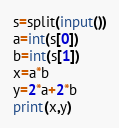Convert code to text. <code><loc_0><loc_0><loc_500><loc_500><_Python_>s=split(input())
a=int(s[0])
b=int(s[1])
x=a*b
y=2*a+2*b
print(x,y)</code> 